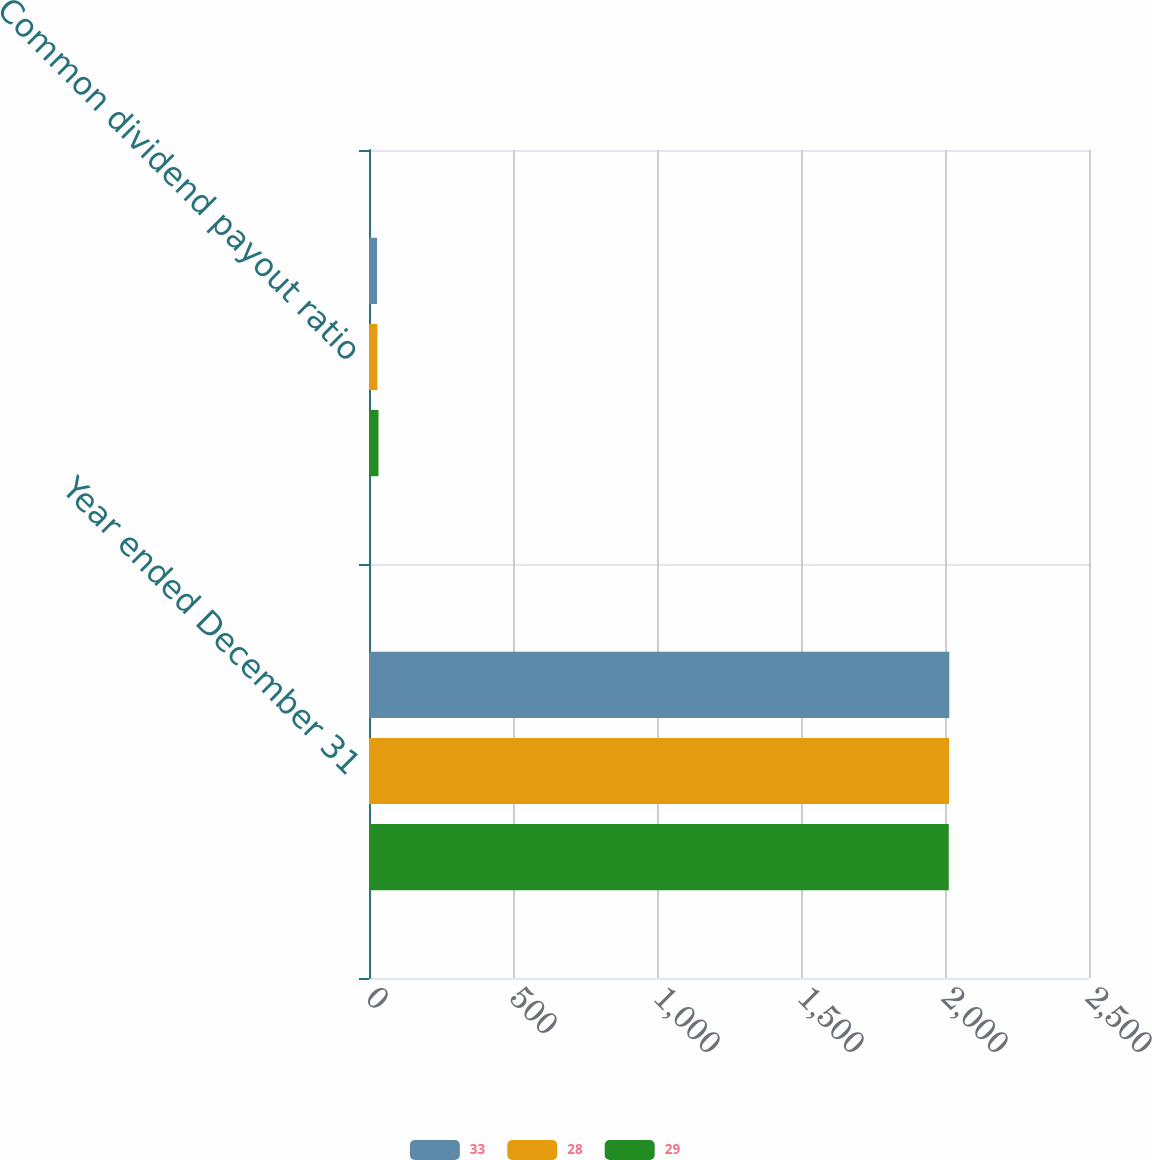Convert chart. <chart><loc_0><loc_0><loc_500><loc_500><stacked_bar_chart><ecel><fcel>Year ended December 31<fcel>Common dividend payout ratio<nl><fcel>33<fcel>2015<fcel>28<nl><fcel>28<fcel>2014<fcel>29<nl><fcel>29<fcel>2013<fcel>33<nl></chart> 